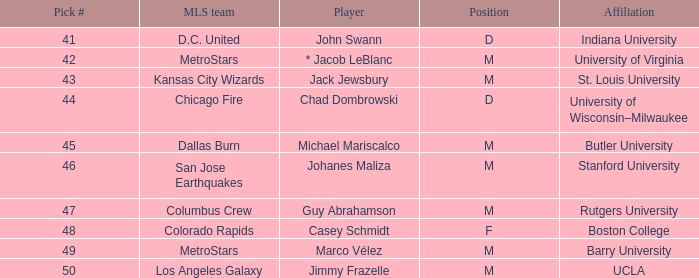What position has UCLA pick that is larger than #47? M. 